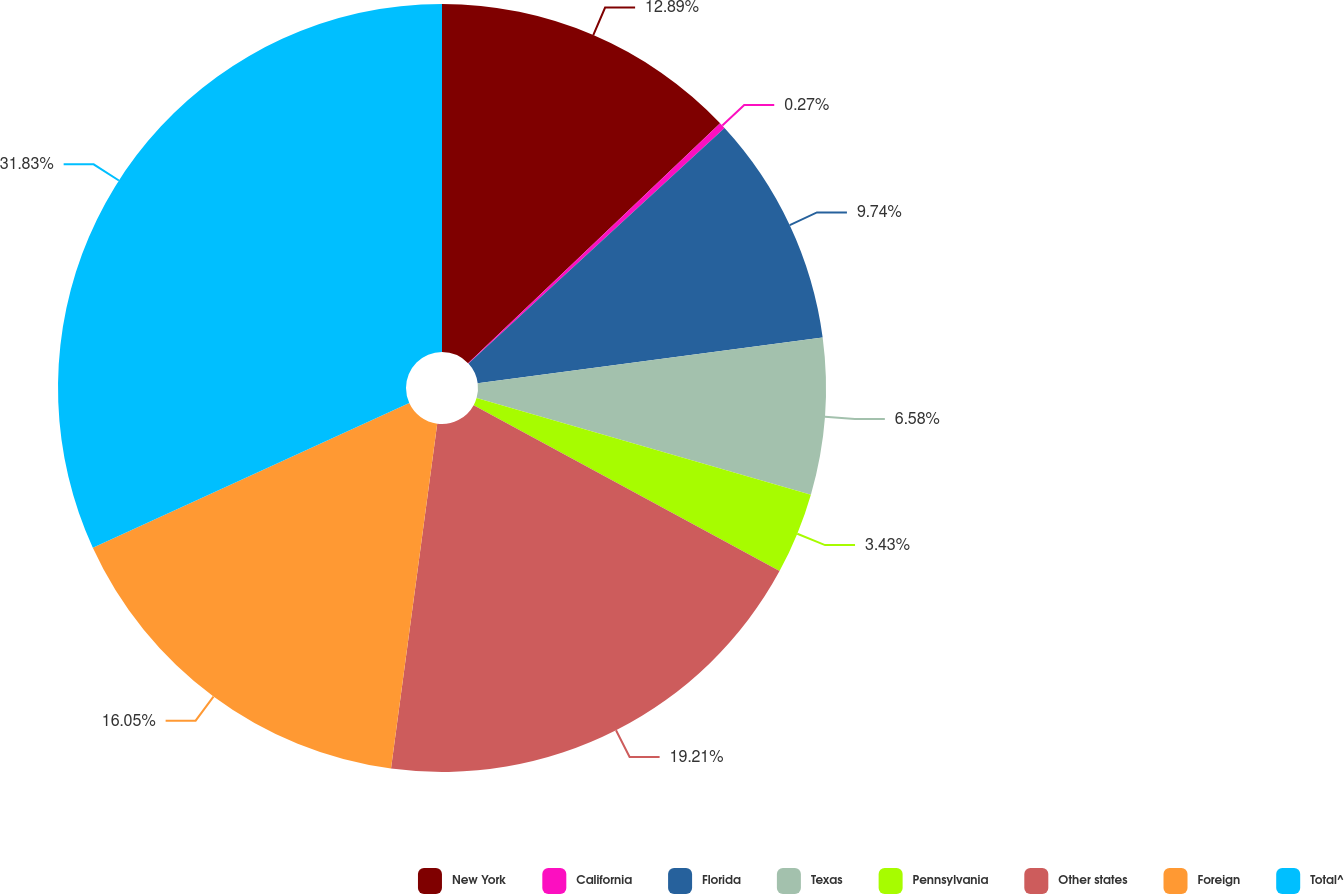Convert chart. <chart><loc_0><loc_0><loc_500><loc_500><pie_chart><fcel>New York<fcel>California<fcel>Florida<fcel>Texas<fcel>Pennsylvania<fcel>Other states<fcel>Foreign<fcel>Total^<nl><fcel>12.89%<fcel>0.27%<fcel>9.74%<fcel>6.58%<fcel>3.43%<fcel>19.21%<fcel>16.05%<fcel>31.83%<nl></chart> 